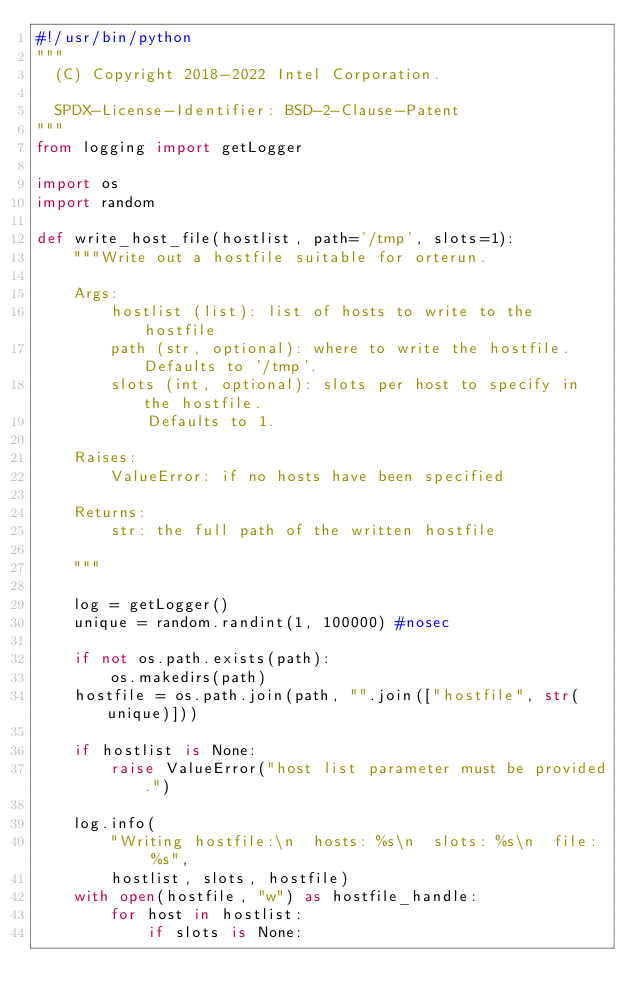Convert code to text. <code><loc_0><loc_0><loc_500><loc_500><_Python_>#!/usr/bin/python
"""
  (C) Copyright 2018-2022 Intel Corporation.

  SPDX-License-Identifier: BSD-2-Clause-Patent
"""
from logging import getLogger

import os
import random

def write_host_file(hostlist, path='/tmp', slots=1):
    """Write out a hostfile suitable for orterun.

    Args:
        hostlist (list): list of hosts to write to the hostfile
        path (str, optional): where to write the hostfile. Defaults to '/tmp'.
        slots (int, optional): slots per host to specify in the hostfile.
            Defaults to 1.

    Raises:
        ValueError: if no hosts have been specified

    Returns:
        str: the full path of the written hostfile

    """

    log = getLogger()
    unique = random.randint(1, 100000) #nosec

    if not os.path.exists(path):
        os.makedirs(path)
    hostfile = os.path.join(path, "".join(["hostfile", str(unique)]))

    if hostlist is None:
        raise ValueError("host list parameter must be provided.")

    log.info(
        "Writing hostfile:\n  hosts: %s\n  slots: %s\n  file:  %s",
        hostlist, slots, hostfile)
    with open(hostfile, "w") as hostfile_handle:
        for host in hostlist:
            if slots is None:</code> 